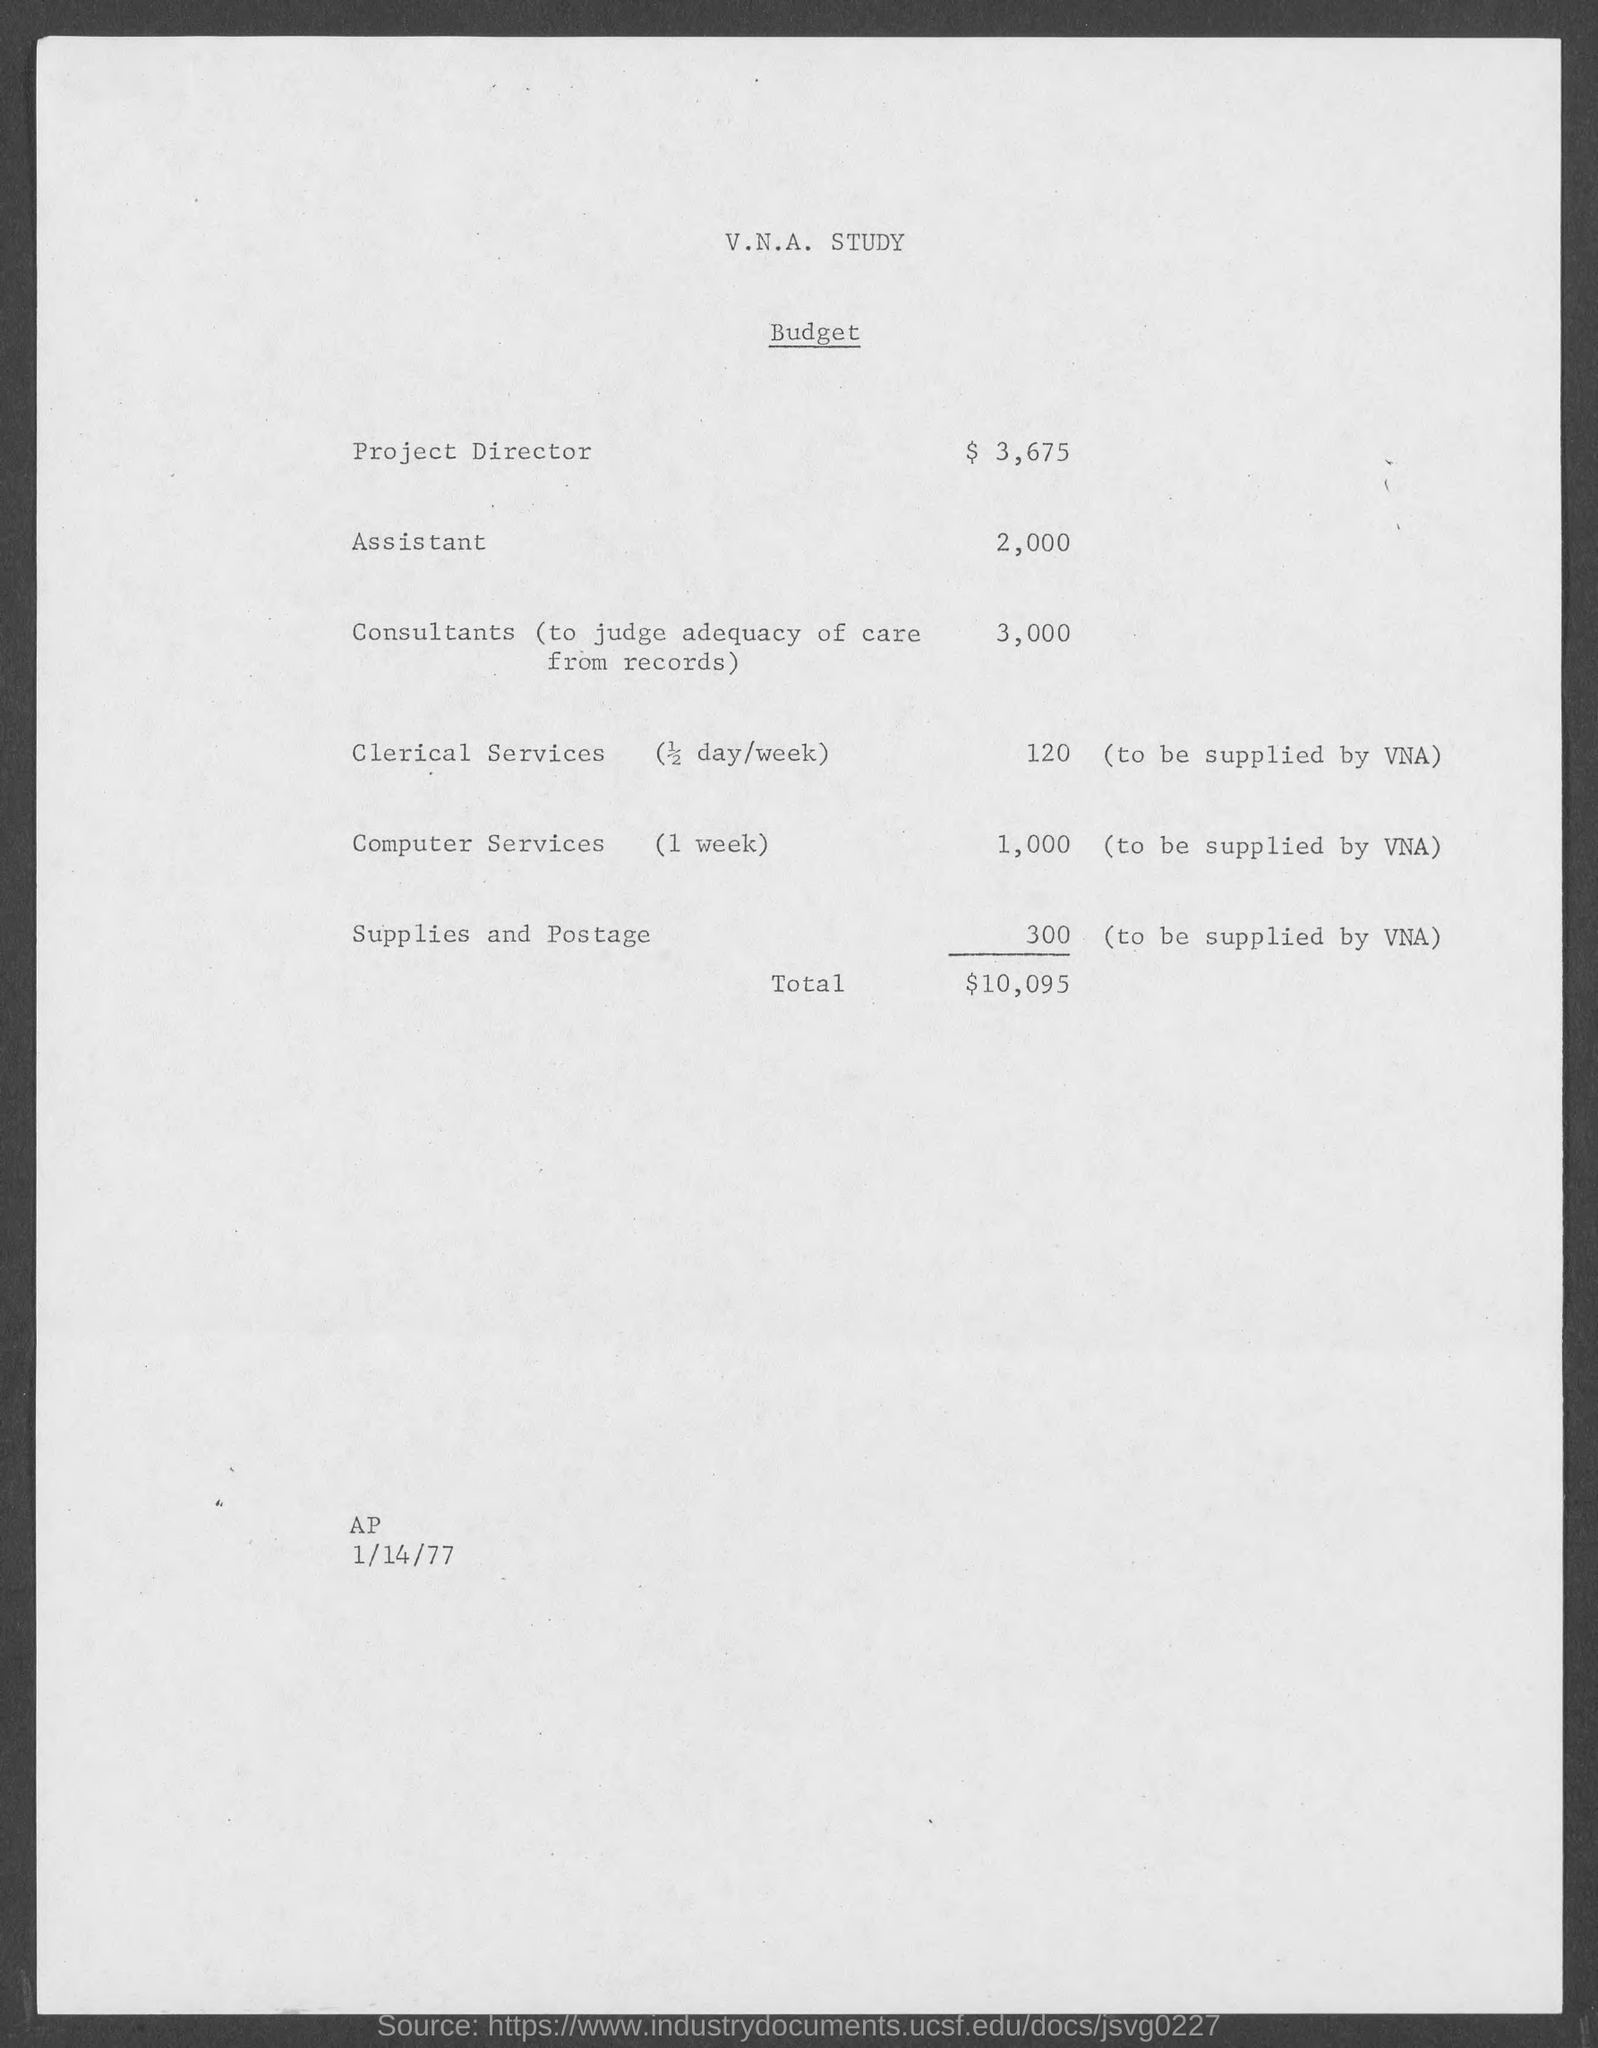What is the Budget Estimate for Project Director?
Make the answer very short. $ 3,675. What is the Total Budget Estimate mentioned in the document?
Offer a very short reply. 10,095. What is the date mentioned in this document?
Ensure brevity in your answer.  1/14/77. 